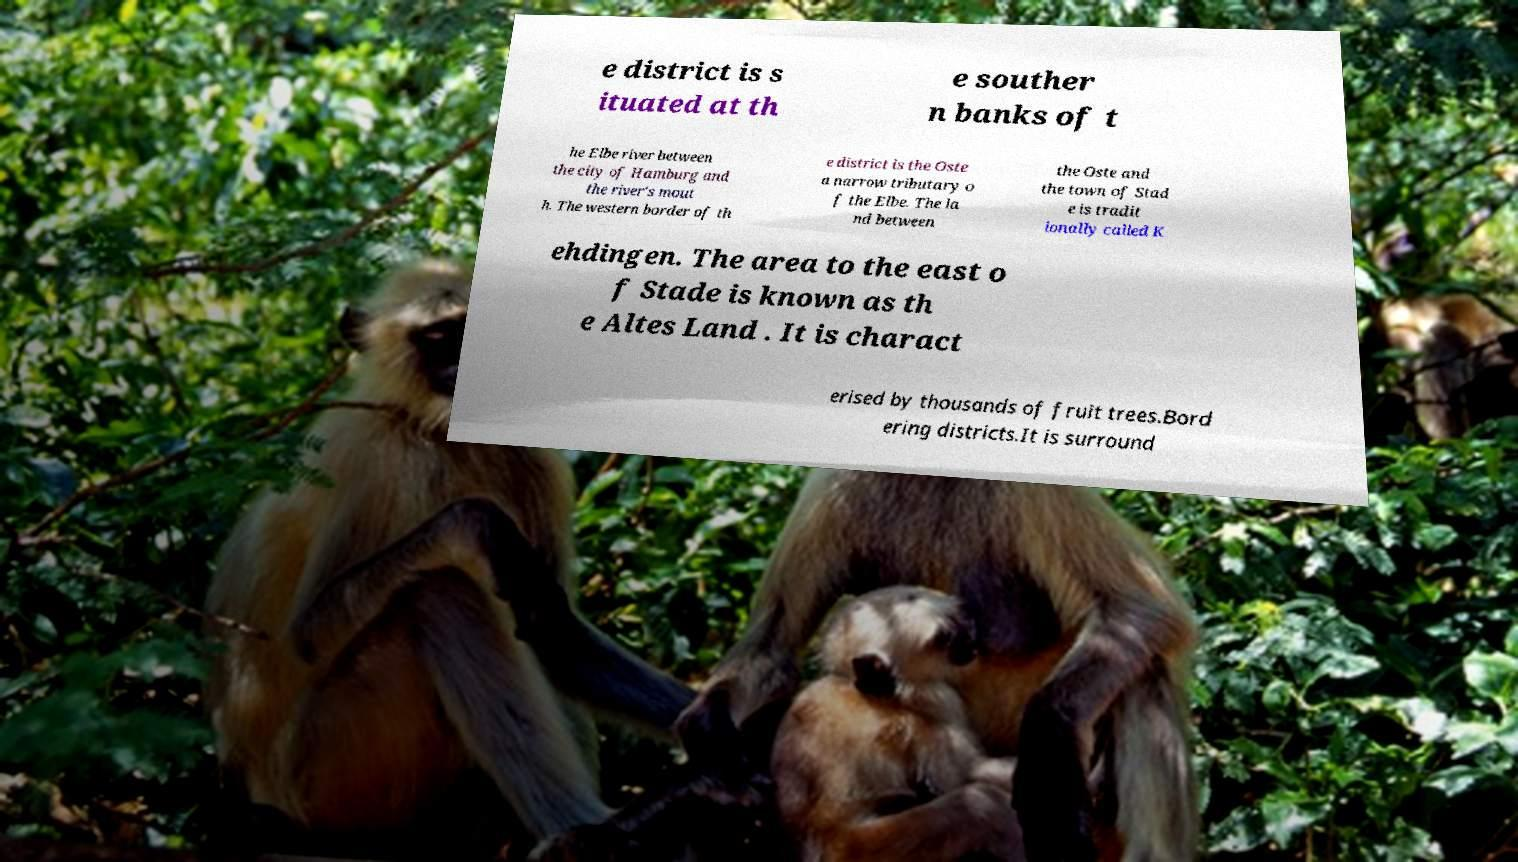Please read and relay the text visible in this image. What does it say? e district is s ituated at th e souther n banks of t he Elbe river between the city of Hamburg and the river's mout h. The western border of th e district is the Oste a narrow tributary o f the Elbe. The la nd between the Oste and the town of Stad e is tradit ionally called K ehdingen. The area to the east o f Stade is known as th e Altes Land . It is charact erised by thousands of fruit trees.Bord ering districts.It is surround 